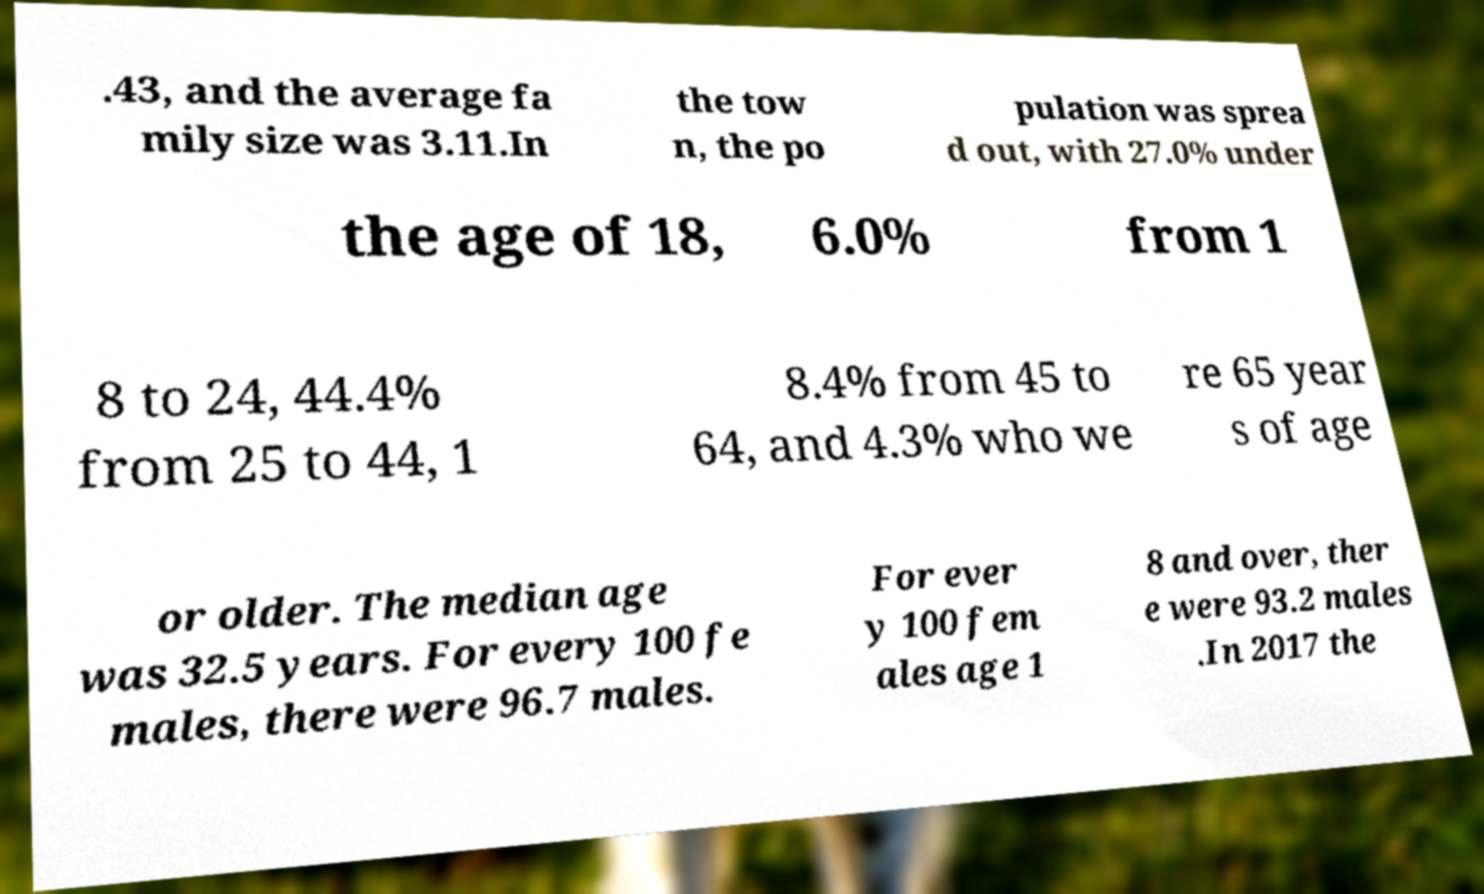Can you accurately transcribe the text from the provided image for me? .43, and the average fa mily size was 3.11.In the tow n, the po pulation was sprea d out, with 27.0% under the age of 18, 6.0% from 1 8 to 24, 44.4% from 25 to 44, 1 8.4% from 45 to 64, and 4.3% who we re 65 year s of age or older. The median age was 32.5 years. For every 100 fe males, there were 96.7 males. For ever y 100 fem ales age 1 8 and over, ther e were 93.2 males .In 2017 the 